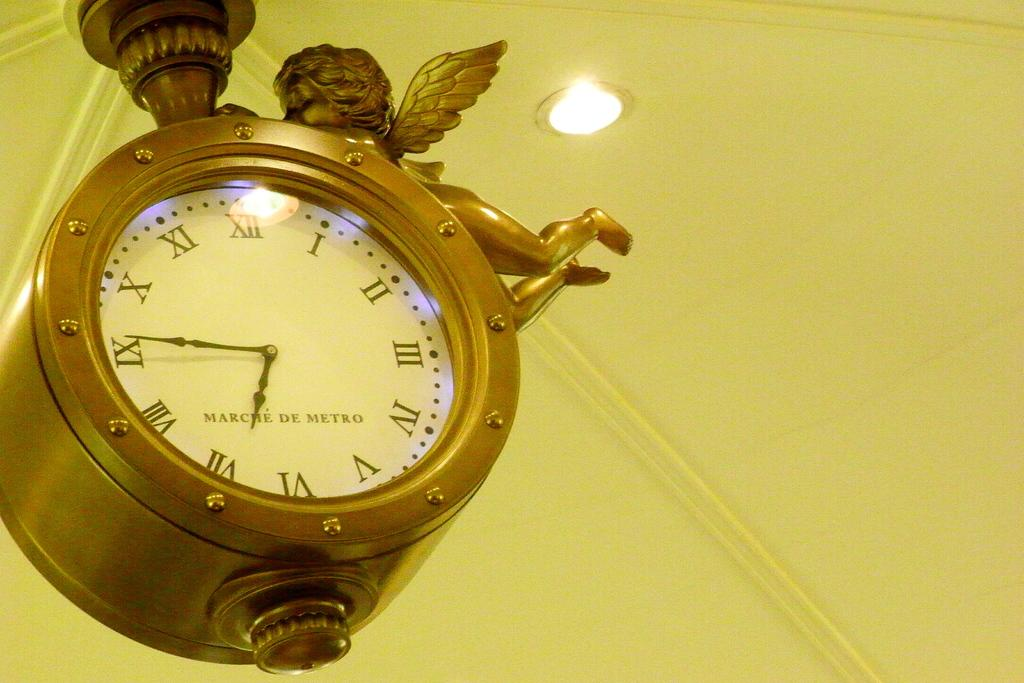<image>
Offer a succinct explanation of the picture presented. A gold colored MARCHE DE METRO clock has a decorative angel on it. 